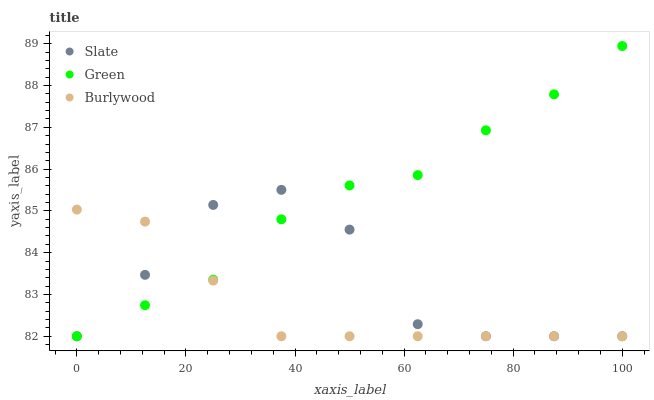Does Burlywood have the minimum area under the curve?
Answer yes or no. Yes. Does Green have the maximum area under the curve?
Answer yes or no. Yes. Does Slate have the minimum area under the curve?
Answer yes or no. No. Does Slate have the maximum area under the curve?
Answer yes or no. No. Is Burlywood the smoothest?
Answer yes or no. Yes. Is Slate the roughest?
Answer yes or no. Yes. Is Green the smoothest?
Answer yes or no. No. Is Green the roughest?
Answer yes or no. No. Does Burlywood have the lowest value?
Answer yes or no. Yes. Does Green have the highest value?
Answer yes or no. Yes. Does Slate have the highest value?
Answer yes or no. No. Does Slate intersect Green?
Answer yes or no. Yes. Is Slate less than Green?
Answer yes or no. No. Is Slate greater than Green?
Answer yes or no. No. 